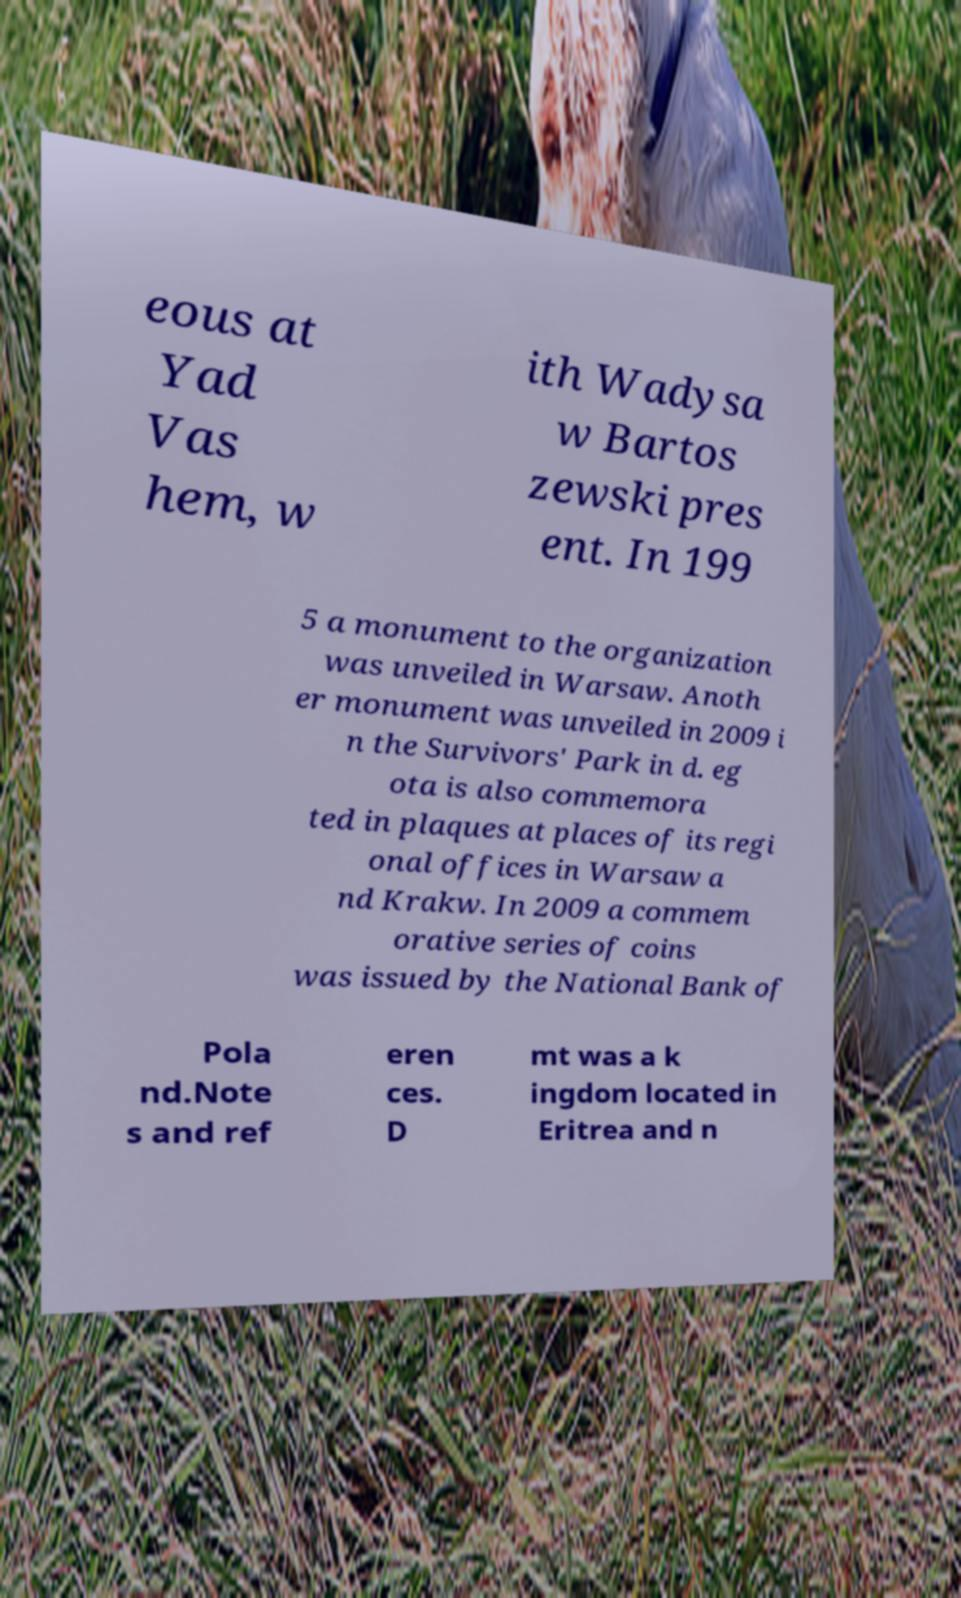Can you accurately transcribe the text from the provided image for me? eous at Yad Vas hem, w ith Wadysa w Bartos zewski pres ent. In 199 5 a monument to the organization was unveiled in Warsaw. Anoth er monument was unveiled in 2009 i n the Survivors' Park in d. eg ota is also commemora ted in plaques at places of its regi onal offices in Warsaw a nd Krakw. In 2009 a commem orative series of coins was issued by the National Bank of Pola nd.Note s and ref eren ces. D mt was a k ingdom located in Eritrea and n 